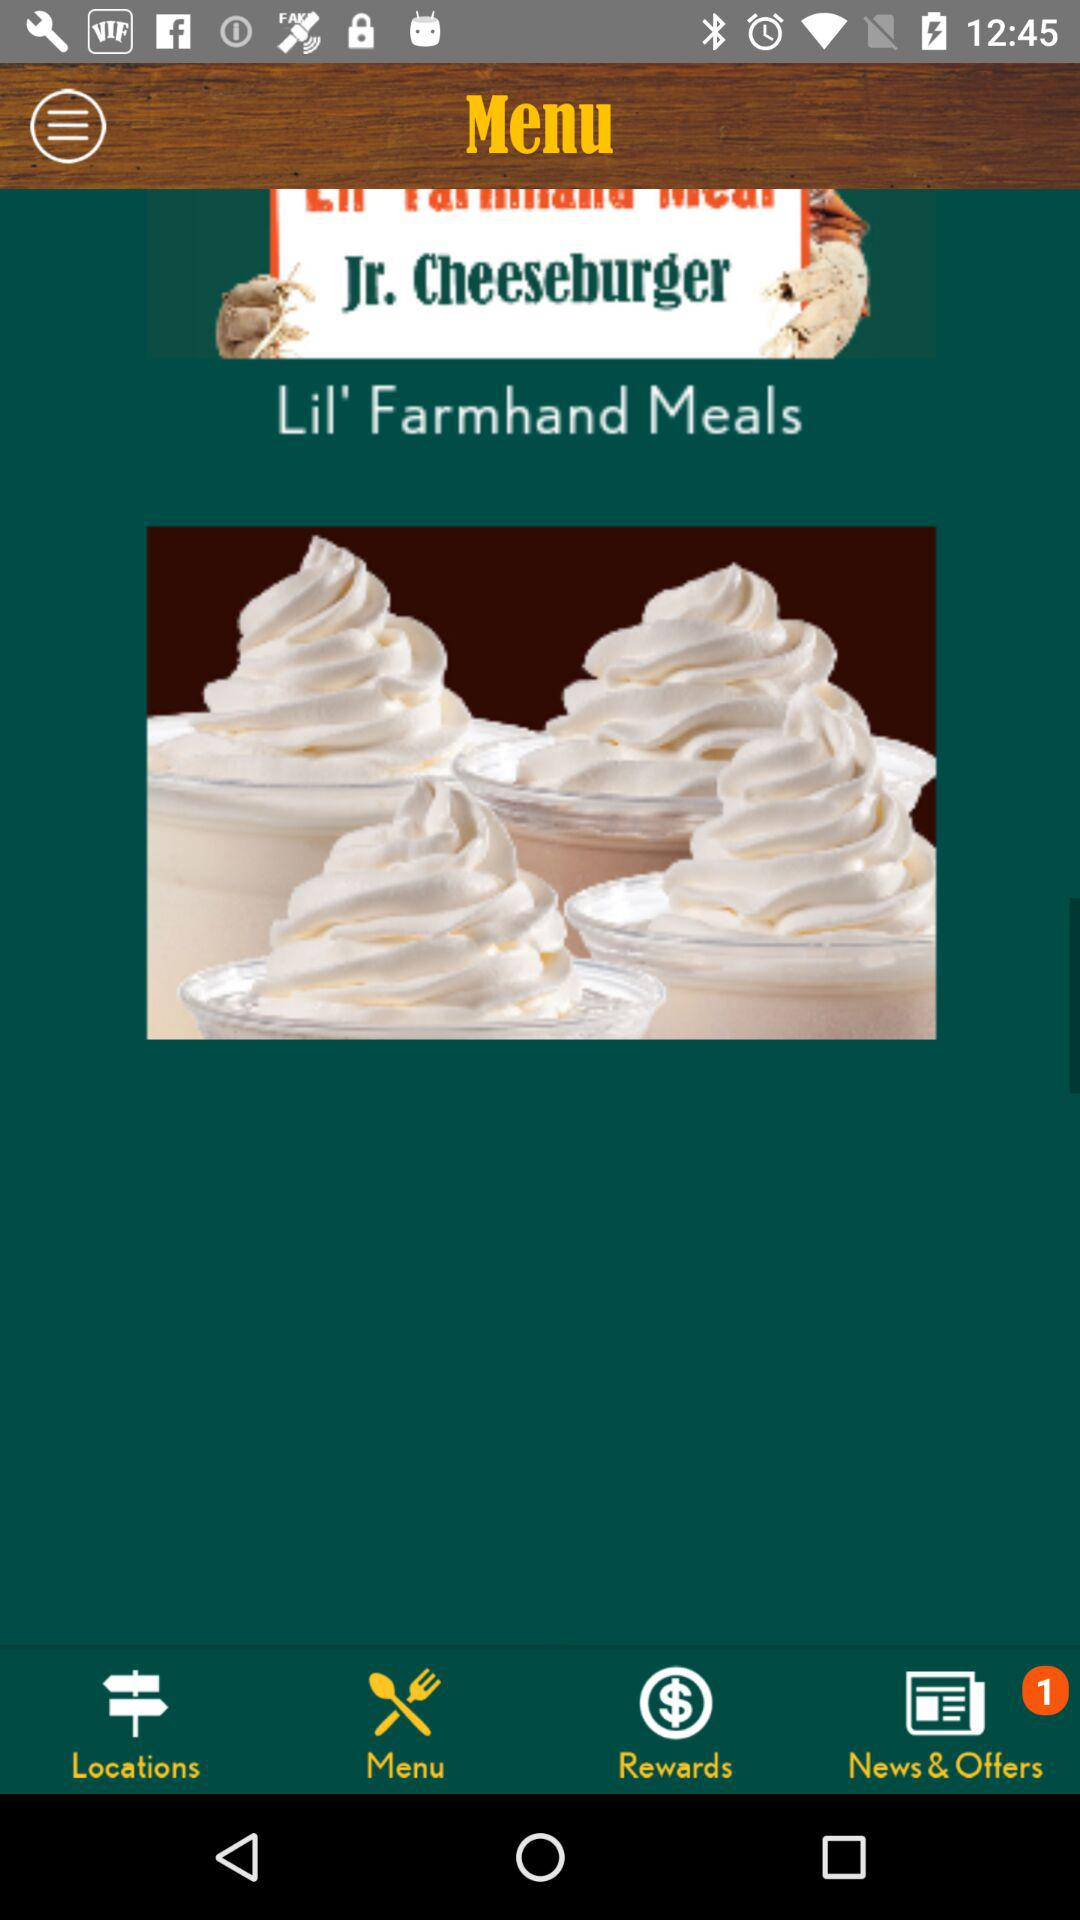Which tab is selected? The selected tab is "Menu". 